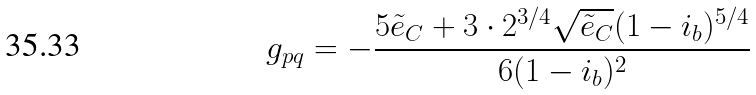Convert formula to latex. <formula><loc_0><loc_0><loc_500><loc_500>g _ { p q } = - \frac { 5 \tilde { e } _ { C } + 3 \cdot 2 ^ { 3 / 4 } \sqrt { \tilde { e } _ { C } } ( 1 - i _ { b } ) ^ { 5 / 4 } } { 6 ( 1 - i _ { b } ) ^ { 2 } }</formula> 